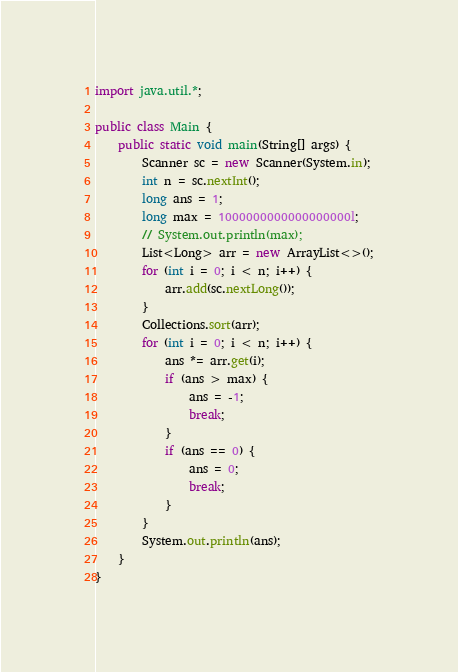<code> <loc_0><loc_0><loc_500><loc_500><_Java_>import java.util.*;

public class Main {
	public static void main(String[] args) {
		Scanner sc = new Scanner(System.in);
		int n = sc.nextInt();
		long ans = 1;
		long max = 1000000000000000000l;
		// System.out.println(max);
		List<Long> arr = new ArrayList<>();
		for (int i = 0; i < n; i++) {
			arr.add(sc.nextLong());
		}
		Collections.sort(arr);
		for (int i = 0; i < n; i++) {
			ans *= arr.get(i);
			if (ans > max) {
				ans = -1;
				break;
			}
			if (ans == 0) {
				ans = 0;
				break;
			}
		}
		System.out.println(ans);
	}
}






</code> 